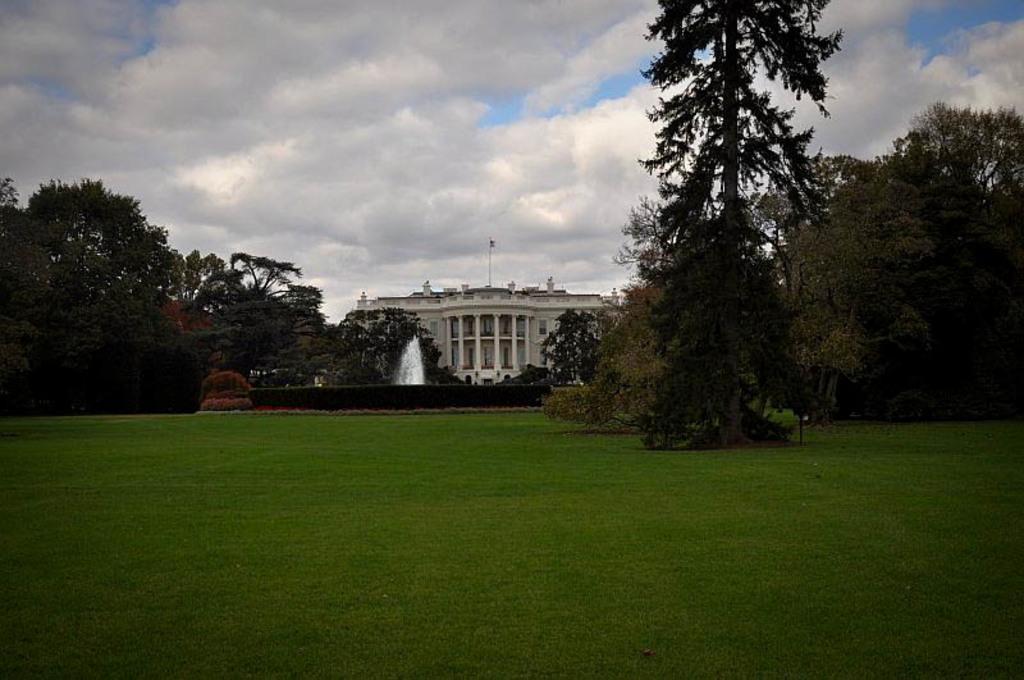How would you summarize this image in a sentence or two? In the foreground of the image there is a grass. In the middle of the image there is a building, in front of the building there is a waterfall. On the right and left side of the image there are trees. In the background there is a sky. 